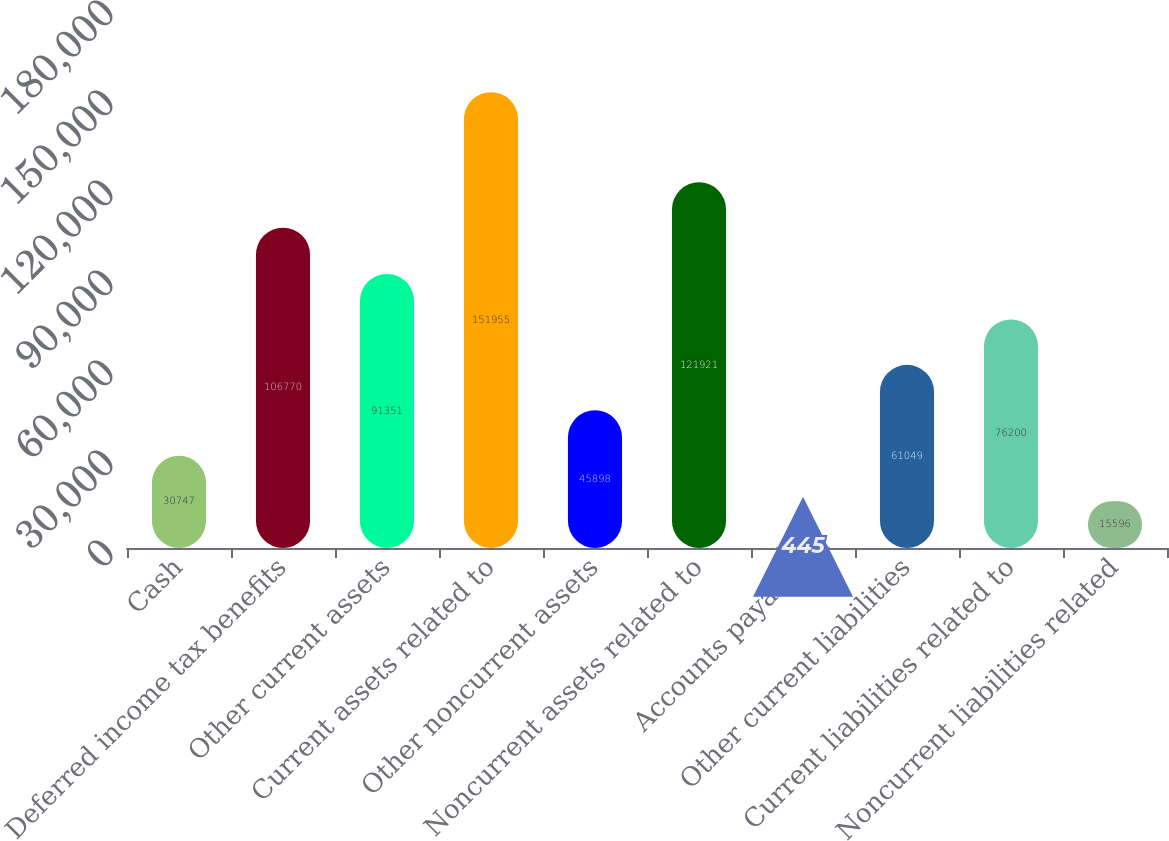<chart> <loc_0><loc_0><loc_500><loc_500><bar_chart><fcel>Cash<fcel>Deferred income tax benefits<fcel>Other current assets<fcel>Current assets related to<fcel>Other noncurrent assets<fcel>Noncurrent assets related to<fcel>Accounts payable<fcel>Other current liabilities<fcel>Current liabilities related to<fcel>Noncurrent liabilities related<nl><fcel>30747<fcel>106770<fcel>91351<fcel>151955<fcel>45898<fcel>121921<fcel>445<fcel>61049<fcel>76200<fcel>15596<nl></chart> 